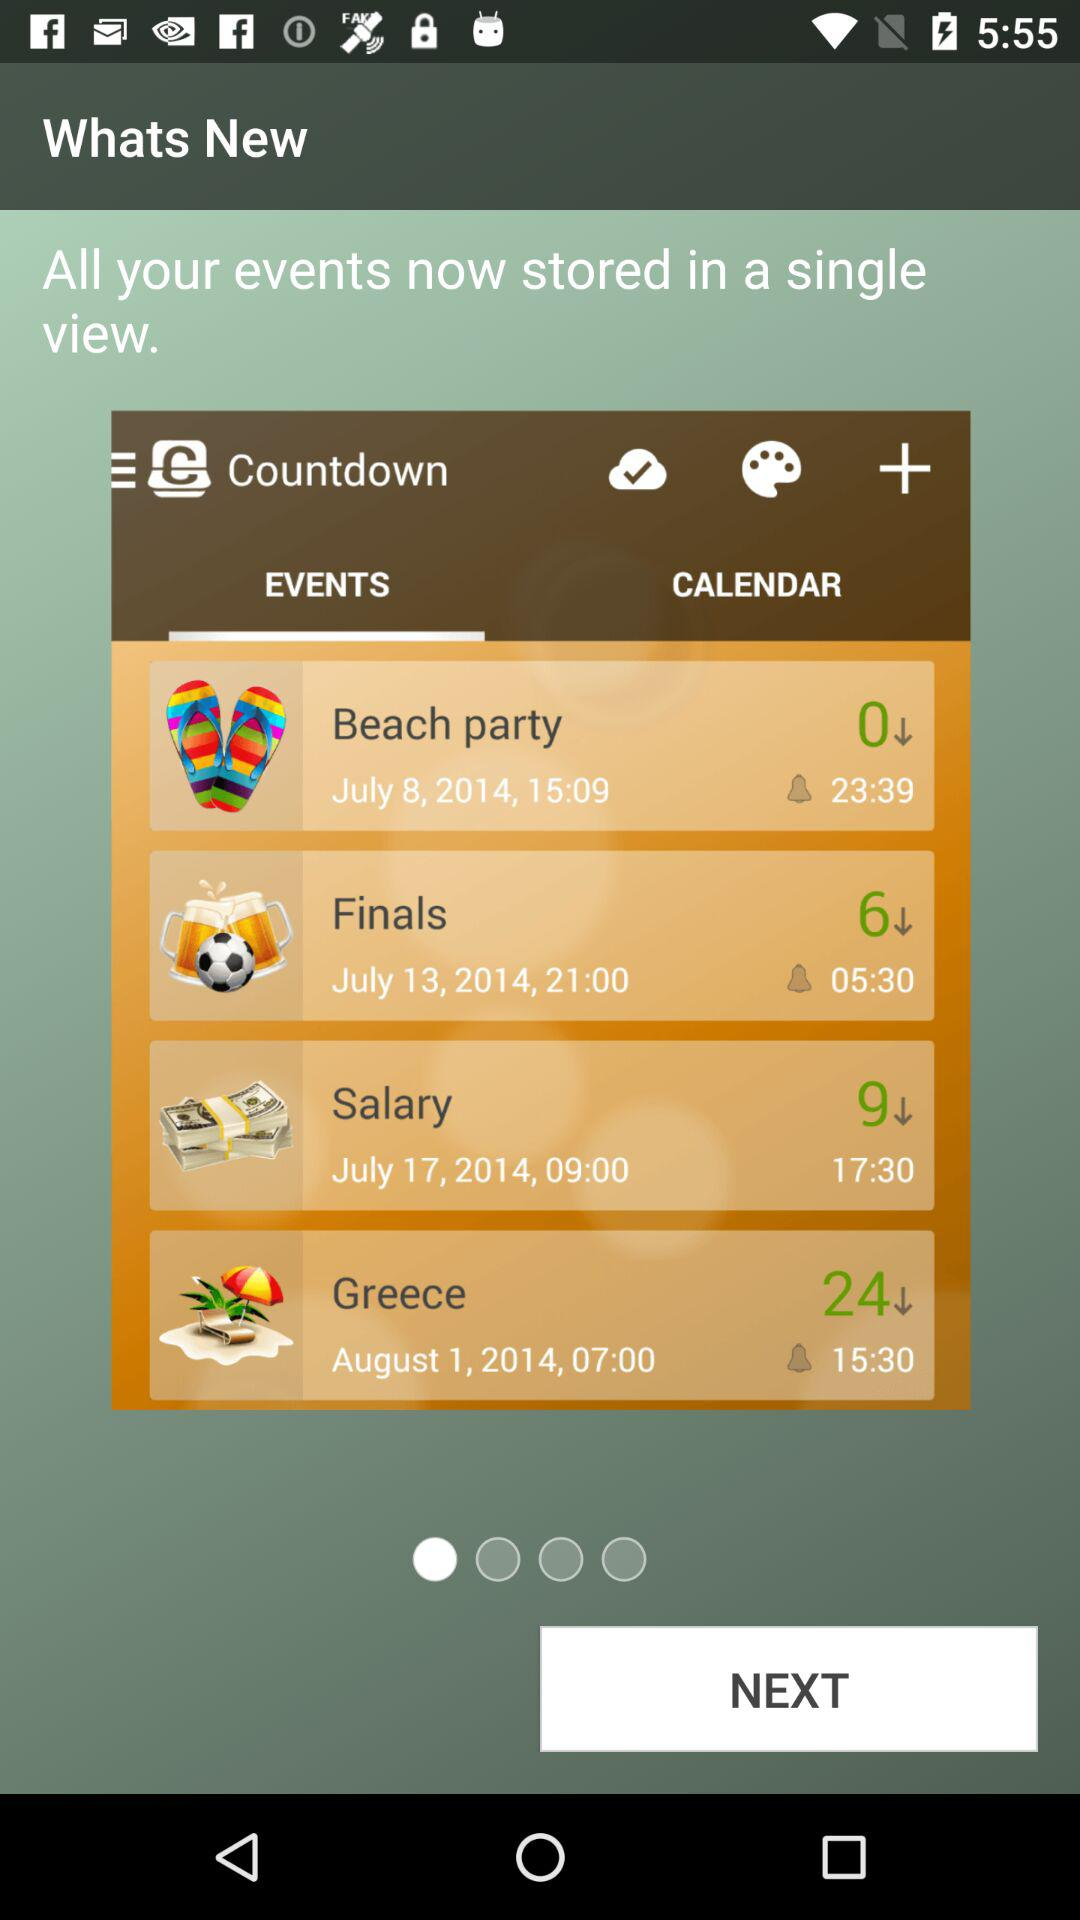What is the date of the "Beach party"? The date is July 8, 2014. 